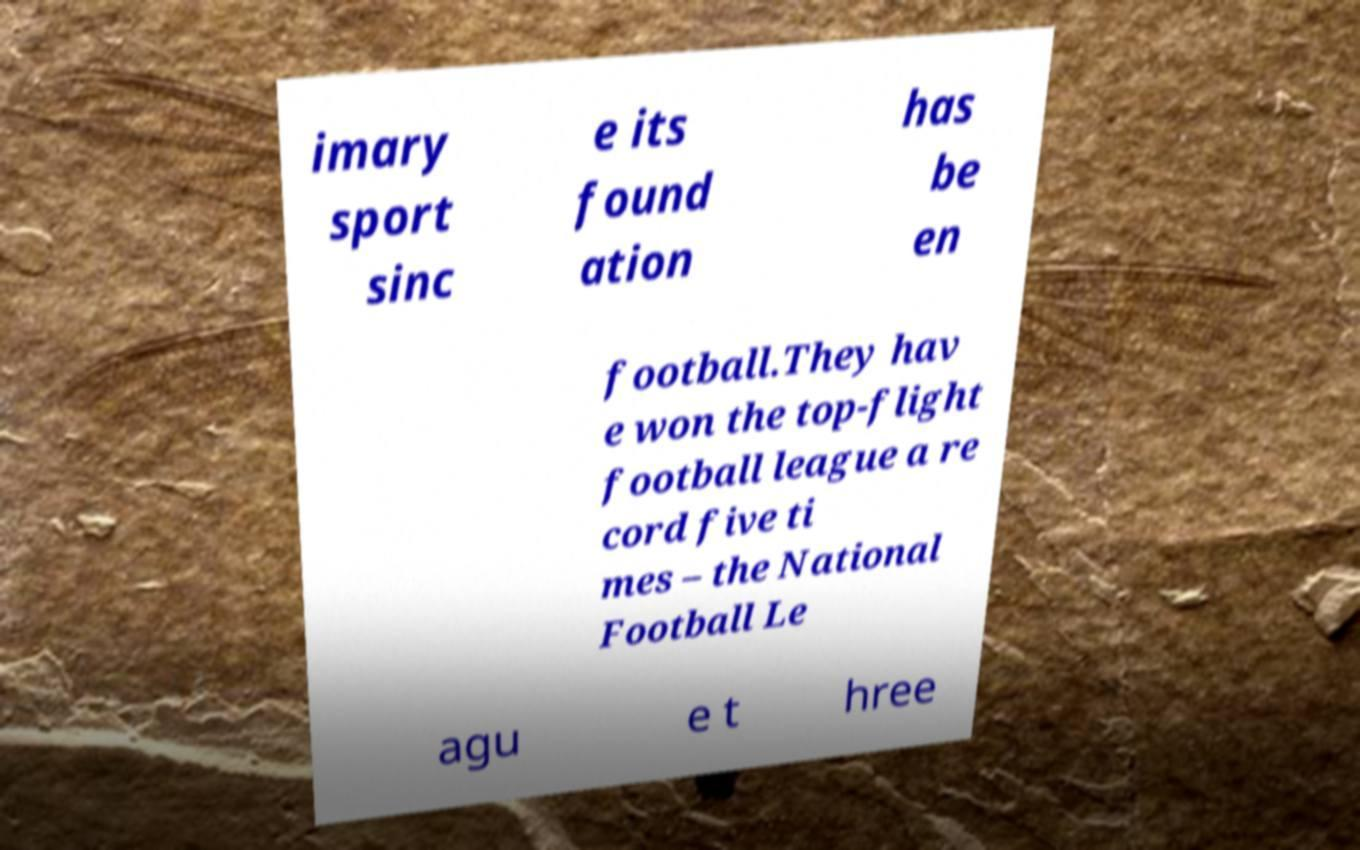Can you read and provide the text displayed in the image?This photo seems to have some interesting text. Can you extract and type it out for me? imary sport sinc e its found ation has be en football.They hav e won the top-flight football league a re cord five ti mes – the National Football Le agu e t hree 